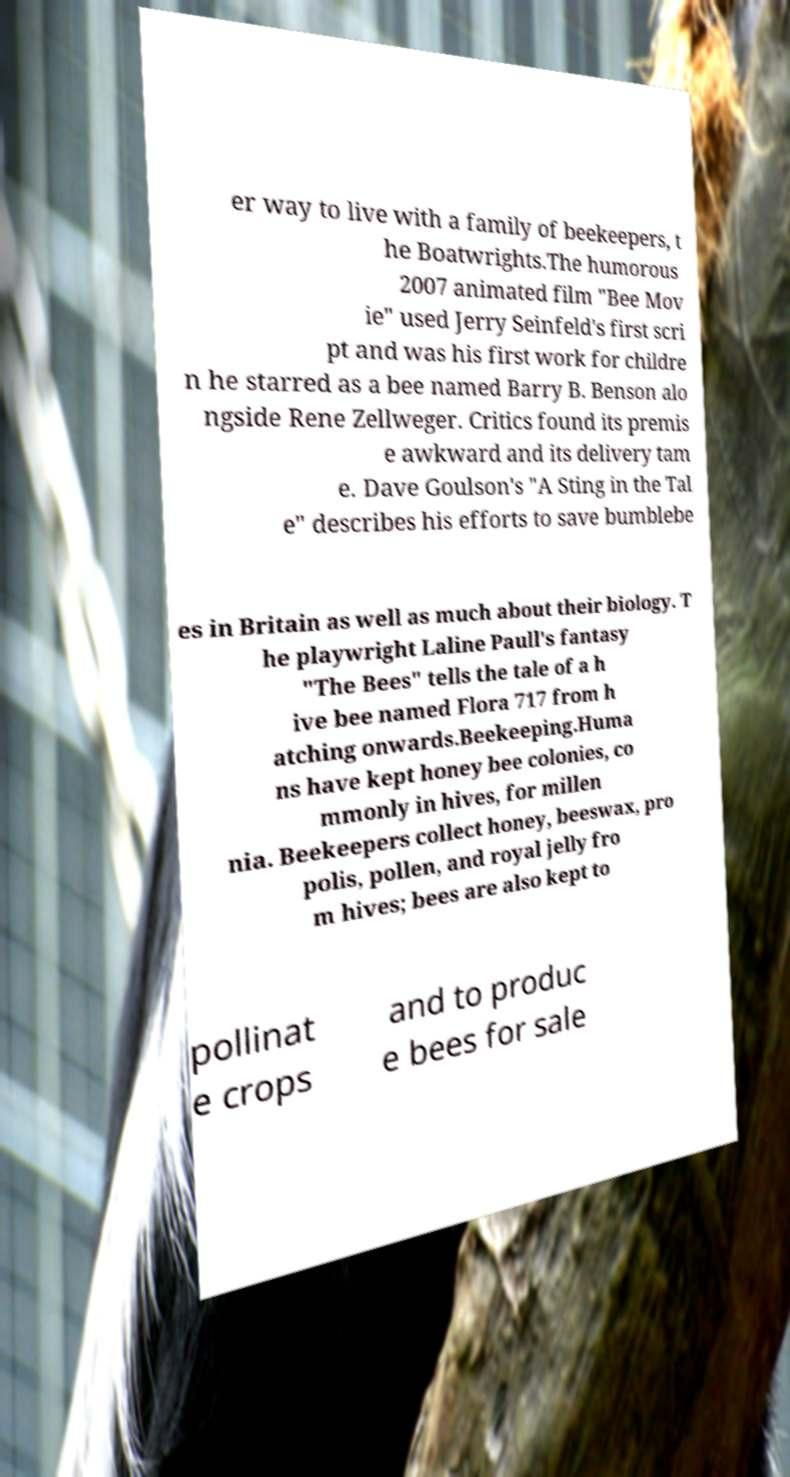Can you read and provide the text displayed in the image?This photo seems to have some interesting text. Can you extract and type it out for me? er way to live with a family of beekeepers, t he Boatwrights.The humorous 2007 animated film "Bee Mov ie" used Jerry Seinfeld's first scri pt and was his first work for childre n he starred as a bee named Barry B. Benson alo ngside Rene Zellweger. Critics found its premis e awkward and its delivery tam e. Dave Goulson's "A Sting in the Tal e" describes his efforts to save bumblebe es in Britain as well as much about their biology. T he playwright Laline Paull's fantasy "The Bees" tells the tale of a h ive bee named Flora 717 from h atching onwards.Beekeeping.Huma ns have kept honey bee colonies, co mmonly in hives, for millen nia. Beekeepers collect honey, beeswax, pro polis, pollen, and royal jelly fro m hives; bees are also kept to pollinat e crops and to produc e bees for sale 